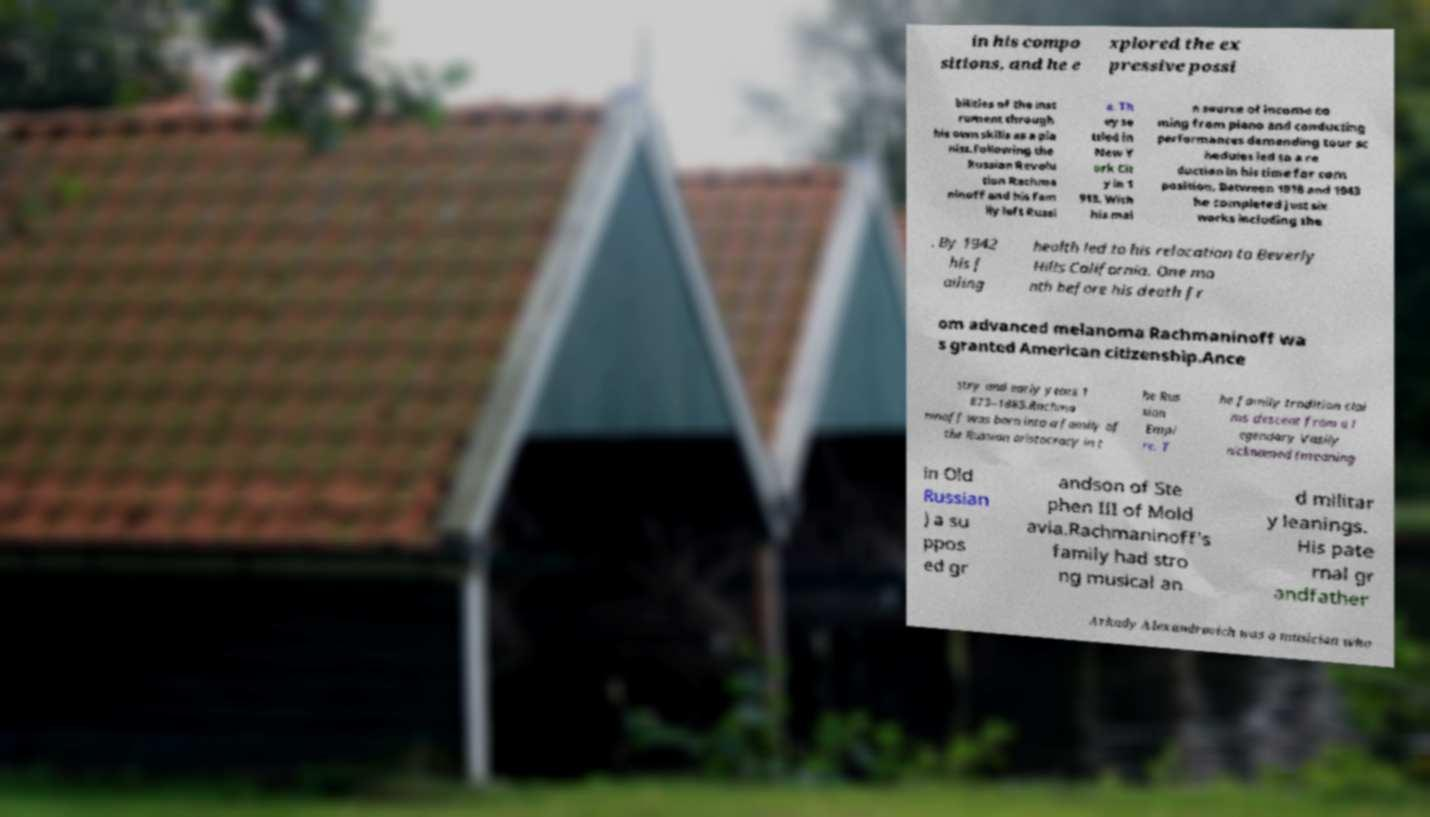What messages or text are displayed in this image? I need them in a readable, typed format. in his compo sitions, and he e xplored the ex pressive possi bilities of the inst rument through his own skills as a pia nist.Following the Russian Revolu tion Rachma ninoff and his fam ily left Russi a. Th ey se ttled in New Y ork Cit y in 1 918. With his mai n source of income co ming from piano and conducting performances demanding tour sc hedules led to a re duction in his time for com position. Between 1918 and 1943 he completed just six works including the . By 1942 his f ailing health led to his relocation to Beverly Hills California. One mo nth before his death fr om advanced melanoma Rachmaninoff wa s granted American citizenship.Ance stry and early years 1 873–1885.Rachma ninoff was born into a family of the Russian aristocracy in t he Rus sian Empi re. T he family tradition clai ms descent from a l egendary Vasily nicknamed (meaning in Old Russian ) a su ppos ed gr andson of Ste phen III of Mold avia.Rachmaninoff's family had stro ng musical an d militar y leanings. His pate rnal gr andfather Arkady Alexandrovich was a musician who 